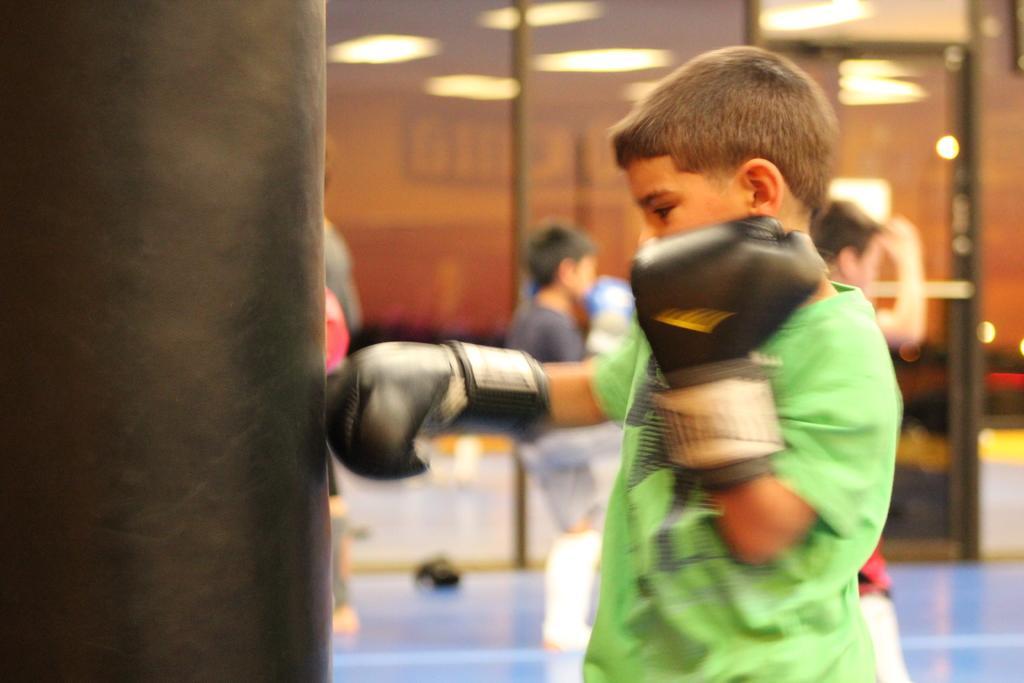Could you give a brief overview of what you see in this image? In the picture we can see a boy standing a wearing boxing gloves and hitting a kick bag and in the background also we can see some boys are standing and they are wearing a boxing gloves and beside them we can see a mirror in it we can see an image of lights to the ceiling. 